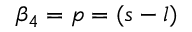<formula> <loc_0><loc_0><loc_500><loc_500>\beta _ { 4 } = p = ( s - l )</formula> 